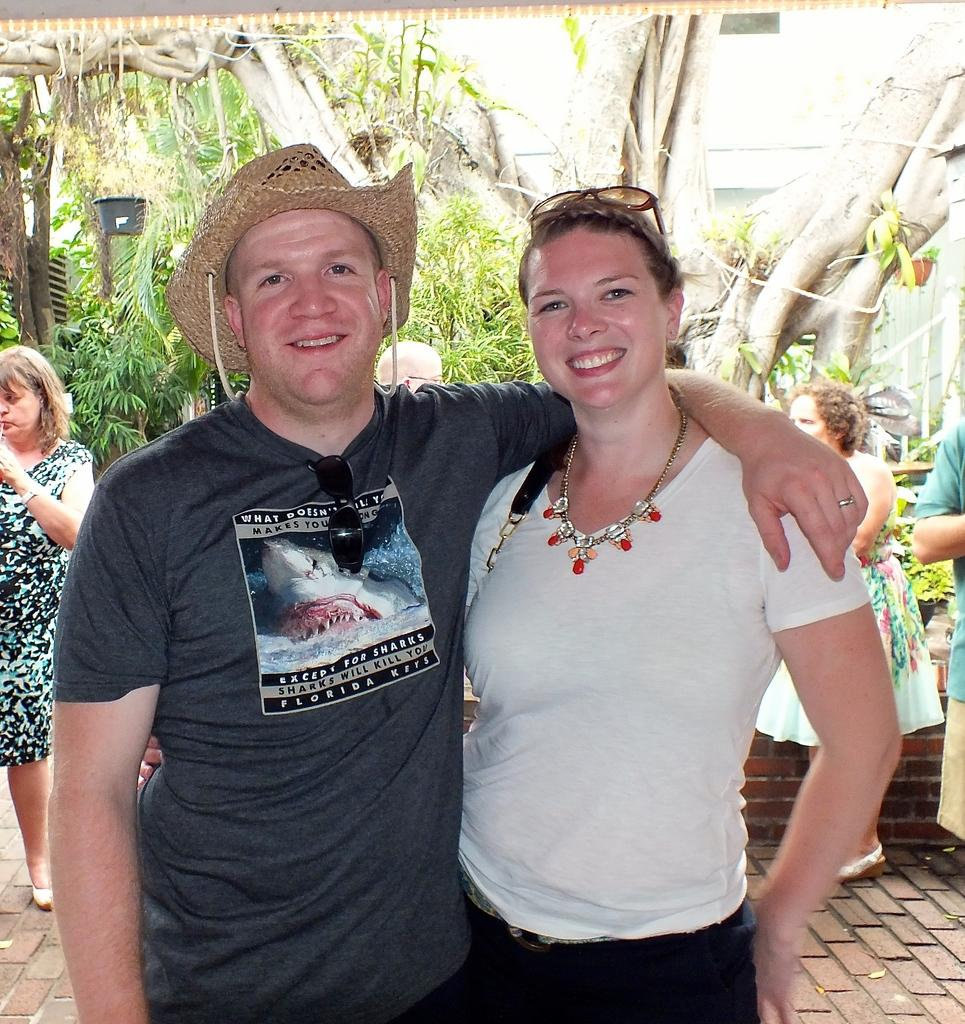How many people are in the image? There are two people in the image. What are the two people doing in the image? The two people are posing for a photo. Can you describe the background of the image? There are other people and many trees in the background of the image. How many tomatoes can be seen growing on the blade in the image? There are no tomatoes or blades present in the image. 